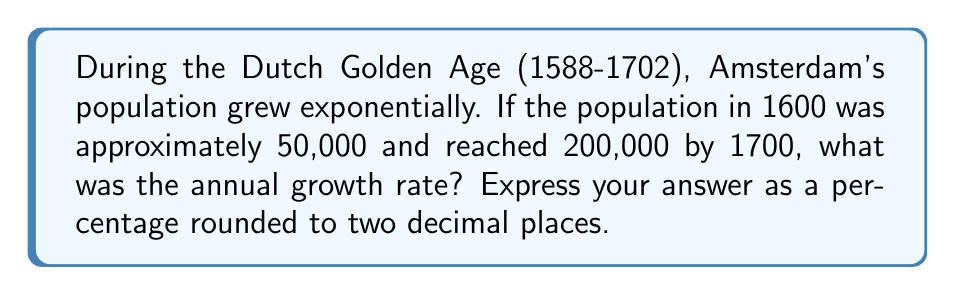Help me with this question. Let's approach this step-by-step using the exponential growth formula:

1) The exponential growth formula is:
   $$ P(t) = P_0 \cdot e^{rt} $$
   Where:
   $P(t)$ is the population at time $t$
   $P_0$ is the initial population
   $r$ is the growth rate
   $t$ is the time period

2) We know:
   $P_0 = 50,000$ (population in 1600)
   $P(t) = 200,000$ (population in 1700)
   $t = 100$ years

3) Plugging these into our formula:
   $$ 200,000 = 50,000 \cdot e^{r \cdot 100} $$

4) Simplify:
   $$ 4 = e^{100r} $$

5) Take the natural log of both sides:
   $$ \ln(4) = 100r $$

6) Solve for $r$:
   $$ r = \frac{\ln(4)}{100} $$

7) Calculate:
   $$ r = \frac{1.386294361}{100} = 0.01386294361 $$

8) Convert to a percentage:
   $$ 0.01386294361 \cdot 100 = 1.386294361\% $$

9) Round to two decimal places:
   $$ 1.39\% $$
Answer: 1.39% 